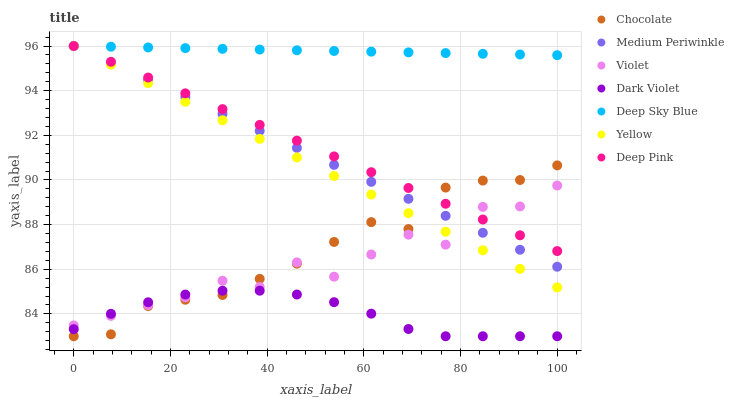Does Dark Violet have the minimum area under the curve?
Answer yes or no. Yes. Does Deep Sky Blue have the maximum area under the curve?
Answer yes or no. Yes. Does Medium Periwinkle have the minimum area under the curve?
Answer yes or no. No. Does Medium Periwinkle have the maximum area under the curve?
Answer yes or no. No. Is Deep Sky Blue the smoothest?
Answer yes or no. Yes. Is Violet the roughest?
Answer yes or no. Yes. Is Medium Periwinkle the smoothest?
Answer yes or no. No. Is Medium Periwinkle the roughest?
Answer yes or no. No. Does Chocolate have the lowest value?
Answer yes or no. Yes. Does Medium Periwinkle have the lowest value?
Answer yes or no. No. Does Deep Sky Blue have the highest value?
Answer yes or no. Yes. Does Chocolate have the highest value?
Answer yes or no. No. Is Dark Violet less than Deep Pink?
Answer yes or no. Yes. Is Yellow greater than Dark Violet?
Answer yes or no. Yes. Does Deep Pink intersect Medium Periwinkle?
Answer yes or no. Yes. Is Deep Pink less than Medium Periwinkle?
Answer yes or no. No. Is Deep Pink greater than Medium Periwinkle?
Answer yes or no. No. Does Dark Violet intersect Deep Pink?
Answer yes or no. No. 